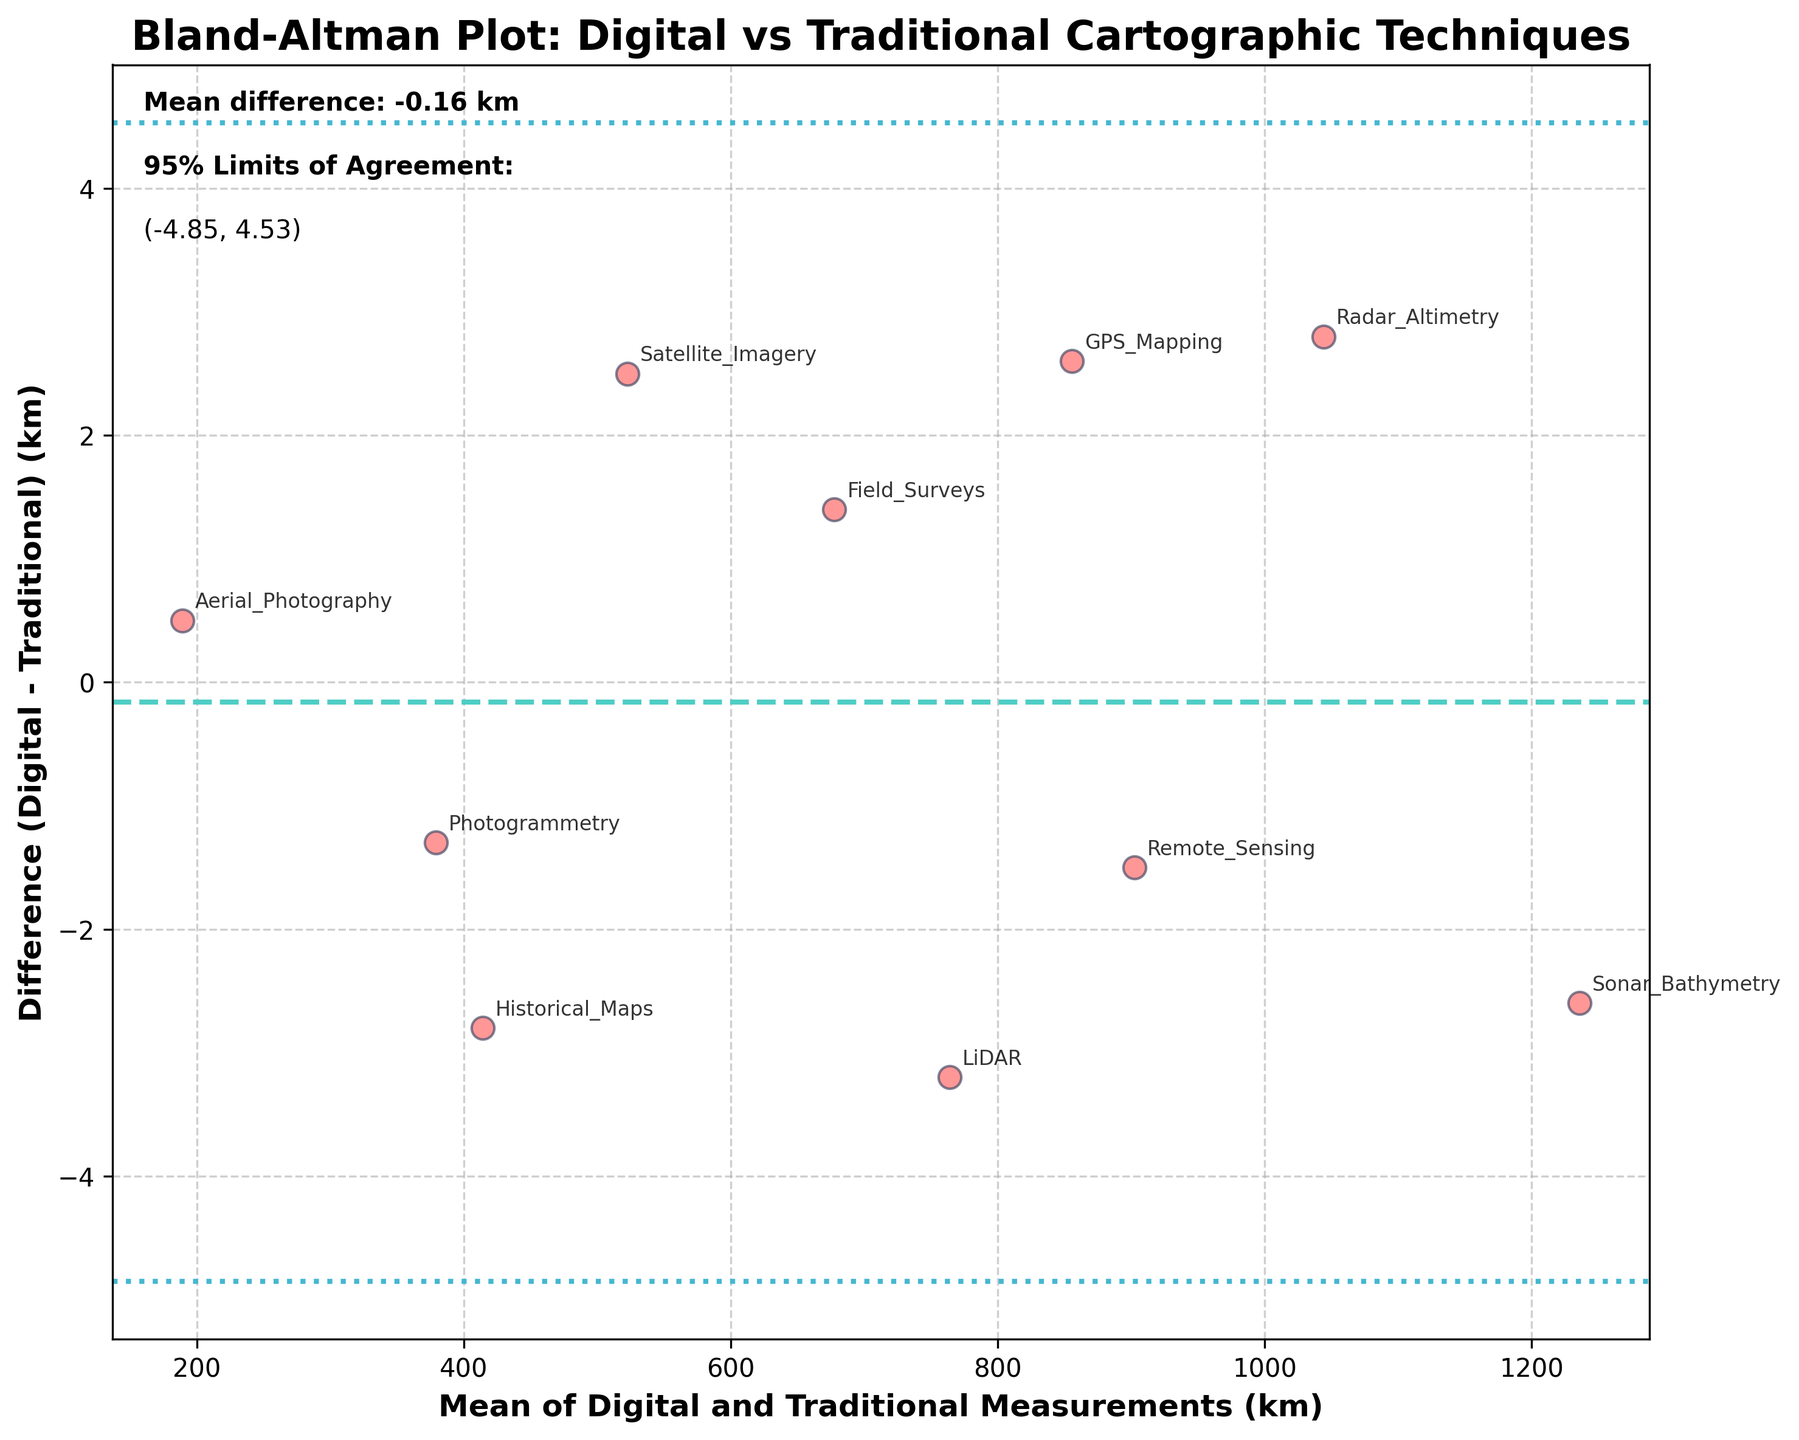What is the main title of the plot? The title of a plot is usually located at the top and it's meant to give an overview of the content the plot is displaying. Here, the main title is "Bland-Altman Plot: Digital vs Traditional Cartographic Techniques".
Answer: Bland-Altman Plot: Digital vs Traditional Cartographic Techniques How many data points are plotted in the Bland-Altman plot? To determine the number of data points, observe the scatter points in the plot. Each point corresponds to a pair of measurements. By counting the plots, we can infer that there are 10 points, representing 10 methods.
Answer: 10 What do the x-axis and y-axis represent in this plot? The x-axis generally displays the average of the Digital and Traditional Measurements (in km), while the y-axis shows the difference between the Digital and Traditional Measurements (in km). This can be inferred from the axis labels provided.
Answer: Mean of Digital and Traditional Measurements (km) and Difference (Digital - Traditional) (km) Which cartographic method has the largest positive difference between Digital and Traditional measurements? To identify the method with the largest positive difference, look for the highest point above the zero line on the y-axis in the plot. Annotate the method label near this point, thus finding that "LiDAR" has the largest positive difference.
Answer: LiDAR What is the mean difference between digital and traditional measurements? The mean difference is typically represented by a horizontal dashed line and also explicitly noted in the textual annotations on the plot. Reading from the annotation or observing the line, the mean difference is approximately calculated.
Answer: -0.29 km What are the 95% limits of agreement? These limits can be found as the horizontal dashed/dotted lines at certain y-values above and below the mean difference line. They are also mentioned in the text annotations. From the annotations, we see the limits of agreement range from approximately -5.34 km to 4.76 km.
Answer: (-5.34, 4.76) km Which methods fall outside the 95% limits of agreement on the plot? To determine which methods fall outside the 95% limits, observe the scatter points that fall above or below the dashed lines representing the limits of agreement. From these points, identify the methods labeled near them.
Answer: GPS Mapping, Sonar Bathymetry Which cartographic method shows the smallest difference between techniques? Look for the scatter point closest to the zero line on the y-axis, which indicates no difference. Annotate the method label near this point; for example, "Aerial Photography" appears the closest.
Answer: Aerial Photography What is indicated by the color and style of the lines in the plot? The dashed line represents the mean difference, while the dotted lines indicate the 95% limits of agreement. Colors may vary but they are meant to distinctly represent these statistical markers.
Answer: Mean difference by dashed line; 95% limits by dotted lines Which method shows a greater average value of the mean for Digital and Traditional measurements? To find the method with the greater average value, look for the scatter point farthest to the right on the x-axis, which corresponds to maximum mean. The method label near this point represents the method in question.
Answer: Sonar Bathymetry 